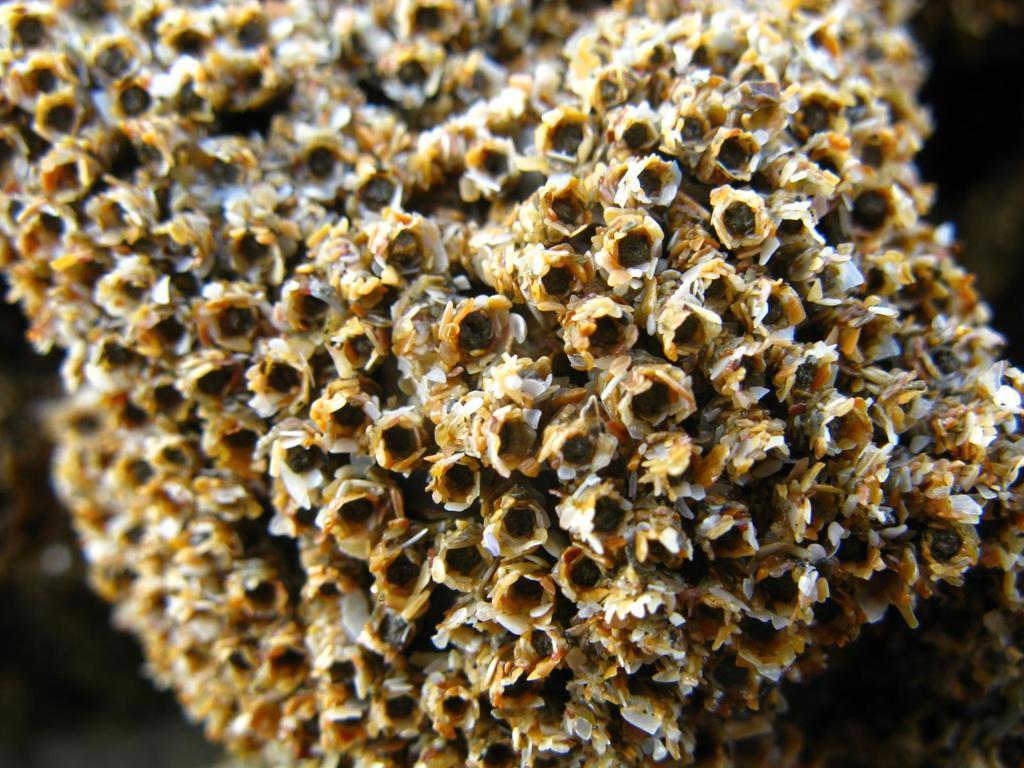Can you describe this image briefly? In this image there is a honeycomb. 